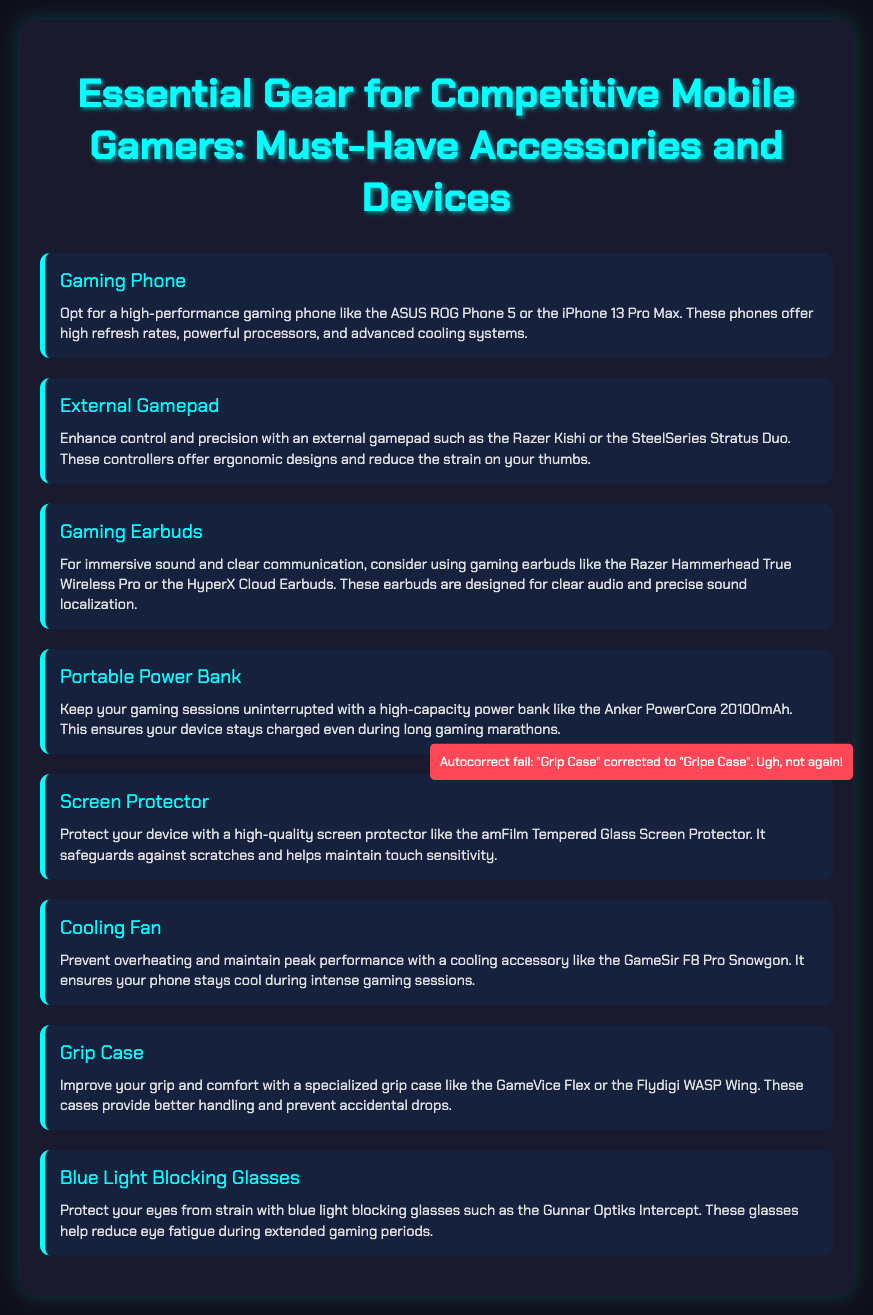what is the title of the document? The title is prominently displayed at the top of the document, introducing the main subject.
Answer: Essential Gear for Competitive Mobile Gamers: Must-Have Accessories and Devices how many items are listed in the gear list? Count each item in the gear list to determine the total number of entries.
Answer: 8 which gaming phone is mentioned first? The first item in the gear list specifically mentions a high-performance gaming phone.
Answer: ASUS ROG Phone 5 what accessory is recommended for immersive sound? This accessory is listed as beneficial for clear audio and sound localization.
Answer: Gaming Earbuds what feature is highlighted for the cooling fan? The cooling fan's purpose is noted for maintaining device performance during usage.
Answer: Prevent overheating what is the purpose of blue light blocking glasses? The document mentions a specific benefit of using these glasses during gaming.
Answer: Protect your eyes from strain which item is designed to prevent accidental drops? This item improves grip and comfort during gaming and is called out specifically in the details.
Answer: Grip Case which power bank model is mentioned? This specific model is referred to as a reliable choice for gamers needing power.
Answer: Anker PowerCore 20100mAh 